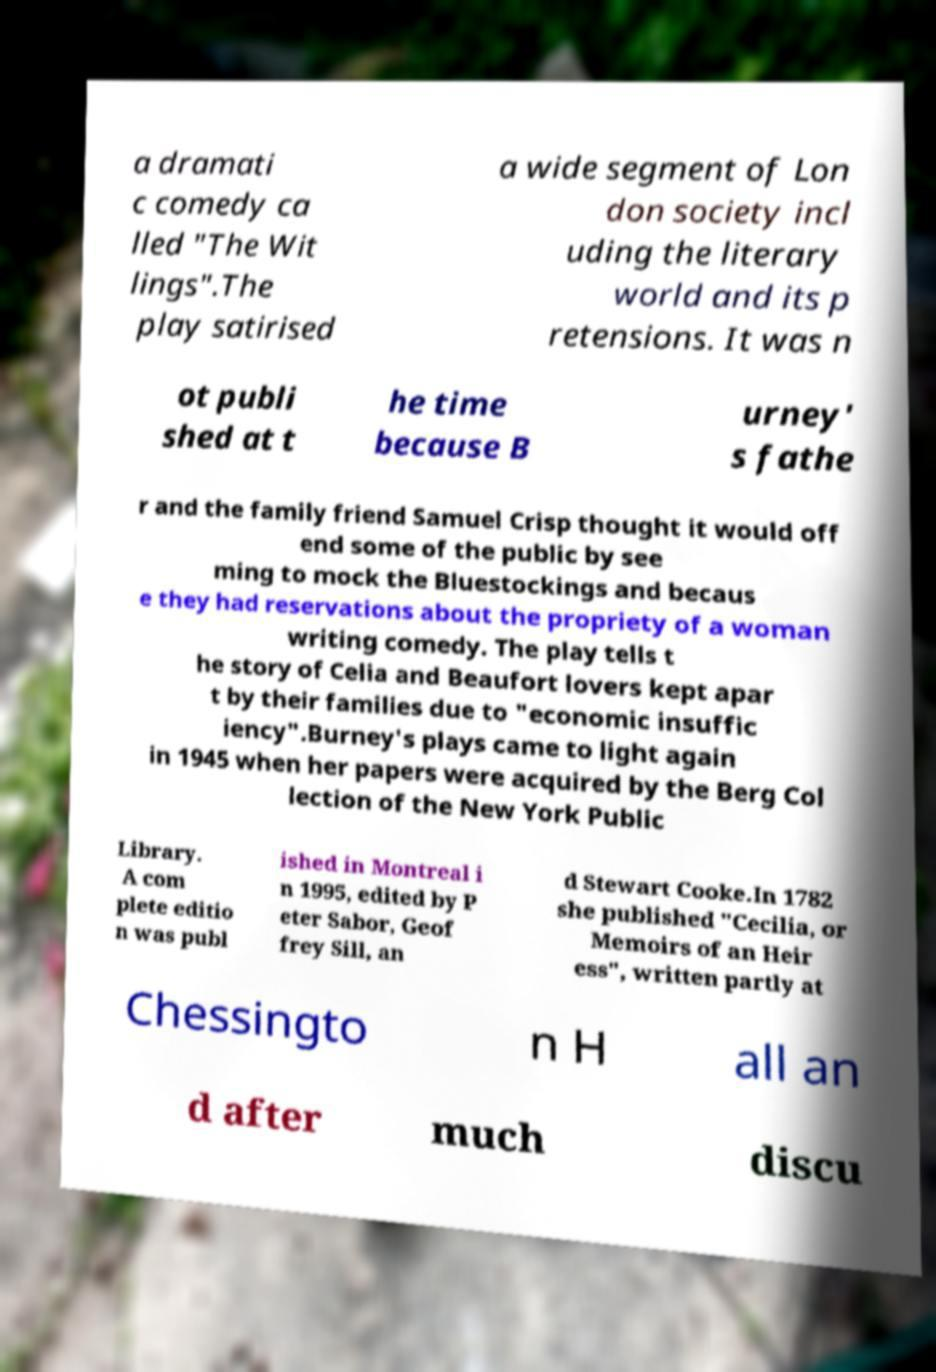Could you extract and type out the text from this image? a dramati c comedy ca lled "The Wit lings".The play satirised a wide segment of Lon don society incl uding the literary world and its p retensions. It was n ot publi shed at t he time because B urney' s fathe r and the family friend Samuel Crisp thought it would off end some of the public by see ming to mock the Bluestockings and becaus e they had reservations about the propriety of a woman writing comedy. The play tells t he story of Celia and Beaufort lovers kept apar t by their families due to "economic insuffic iency".Burney's plays came to light again in 1945 when her papers were acquired by the Berg Col lection of the New York Public Library. A com plete editio n was publ ished in Montreal i n 1995, edited by P eter Sabor, Geof frey Sill, an d Stewart Cooke.In 1782 she published "Cecilia, or Memoirs of an Heir ess", written partly at Chessingto n H all an d after much discu 